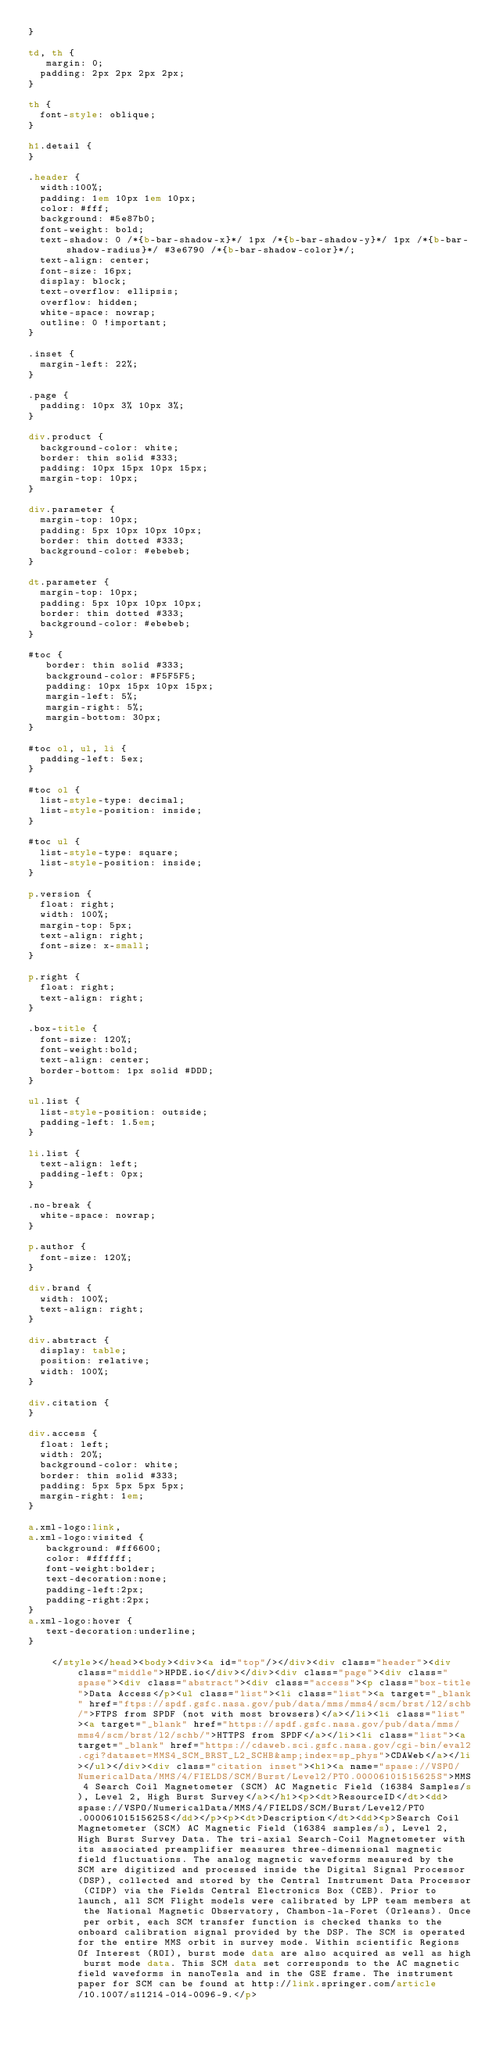<code> <loc_0><loc_0><loc_500><loc_500><_HTML_>}

td, th {
   margin: 0;
	padding: 2px 2px 2px 2px;
}

th {
	font-style: oblique;
}

h1.detail {
}

.header {
	width:100%;
	padding: 1em 10px 1em 10px;
	color: #fff;
	background: #5e87b0;
	font-weight: bold;
	text-shadow: 0 /*{b-bar-shadow-x}*/ 1px /*{b-bar-shadow-y}*/ 1px /*{b-bar-shadow-radius}*/ #3e6790 /*{b-bar-shadow-color}*/;
	text-align: center;
	font-size: 16px;
	display: block;
	text-overflow: ellipsis;
	overflow: hidden;
	white-space: nowrap;
	outline: 0 !important;
}

.inset {
	margin-left: 22%;
}

.page {
	padding: 10px 3% 10px 3%;
}

div.product {
	background-color: white;
	border: thin solid #333;
	padding: 10px 15px 10px 15px;
	margin-top: 10px;
}

div.parameter {
	margin-top: 10px;
	padding: 5px 10px 10px 10px;
	border: thin dotted #333;
	background-color: #ebebeb;
}

dt.parameter {
	margin-top: 10px;
	padding: 5px 10px 10px 10px;
	border: thin dotted #333;
	background-color: #ebebeb;
}

#toc {
   border: thin solid #333;
   background-color: #F5F5F5; 
   padding: 10px 15px 10px 15px;
   margin-left: 5%;
   margin-right: 5%;
   margin-bottom: 30px;
}

#toc ol, ul, li {
	padding-left: 5ex;
}

#toc ol {
	list-style-type: decimal;
	list-style-position: inside; 
}

#toc ul {
	list-style-type: square;
	list-style-position: inside; 
}

p.version {
  float: right;
  width: 100%;
  margin-top: 5px;
  text-align: right;
  font-size: x-small;
}

p.right {
  float: right;
  text-align: right;
}

.box-title {
	font-size: 120%;
	font-weight:bold;
	text-align: center;
	border-bottom: 1px solid #DDD;
}

ul.list {
	list-style-position: outside;
	padding-left: 1.5em;
}

li.list {
	text-align: left;
	padding-left: 0px;
}

.no-break {
	white-space: nowrap;
}

p.author {
	font-size: 120%;
}

div.brand {
	width: 100%;
	text-align: right;
}

div.abstract {
	display: table;
	position: relative;
	width: 100%;
}

div.citation {
}

div.access {
	float: left;
	width: 20%;
	background-color: white;
	border: thin solid #333;
	padding: 5px 5px 5px 5px;
	margin-right: 1em;
}

a.xml-logo:link,
a.xml-logo:visited {
   background: #ff6600;
   color: #ffffff;
   font-weight:bolder; 
   text-decoration:none; 
   padding-left:2px;
   padding-right:2px;
}
a.xml-logo:hover {
   text-decoration:underline; 
}

	  </style></head><body><div><a id="top"/></div><div class="header"><div class="middle">HPDE.io</div></div><div class="page"><div class="spase"><div class="abstract"><div class="access"><p class="box-title">Data Access</p><ul class="list"><li class="list"><a target="_blank" href="ftps://spdf.gsfc.nasa.gov/pub/data/mms/mms4/scm/brst/l2/schb/">FTPS from SPDF (not with most browsers)</a></li><li class="list"><a target="_blank" href="https://spdf.gsfc.nasa.gov/pub/data/mms/mms4/scm/brst/l2/schb/">HTTPS from SPDF</a></li><li class="list"><a target="_blank" href="https://cdaweb.sci.gsfc.nasa.gov/cgi-bin/eval2.cgi?dataset=MMS4_SCM_BRST_L2_SCHB&amp;index=sp_phys">CDAWeb</a></li></ul></div><div class="citation inset"><h1><a name="spase://VSPO/NumericalData/MMS/4/FIELDS/SCM/Burst/Level2/PT0.00006101515625S">MMS 4 Search Coil Magnetometer (SCM) AC Magnetic Field (16384 Samples/s), Level 2, High Burst Survey</a></h1><p><dt>ResourceID</dt><dd>spase://VSPO/NumericalData/MMS/4/FIELDS/SCM/Burst/Level2/PT0.00006101515625S</dd></p><p><dt>Description</dt><dd><p>Search Coil Magnetometer (SCM) AC Magnetic Field (16384 samples/s), Level 2, High Burst Survey Data. The tri-axial Search-Coil Magnetometer with its associated preamplifier measures three-dimensional magnetic field fluctuations. The analog magnetic waveforms measured by the SCM are digitized and processed inside the Digital Signal Processor (DSP), collected and stored by the Central Instrument Data Processor (CIDP) via the Fields Central Electronics Box (CEB). Prior to launch, all SCM Flight models were calibrated by LPP team members at the National Magnetic Observatory, Chambon-la-Foret (Orleans). Once per orbit, each SCM transfer function is checked thanks to the onboard calibration signal provided by the DSP. The SCM is operated for the entire MMS orbit in survey mode. Within scientific Regions Of Interest (ROI), burst mode data are also acquired as well as high burst mode data. This SCM data set corresponds to the AC magnetic field waveforms in nanoTesla and in the GSE frame. The instrument paper for SCM can be found at http://link.springer.com/article/10.1007/s11214-014-0096-9.</p></code> 